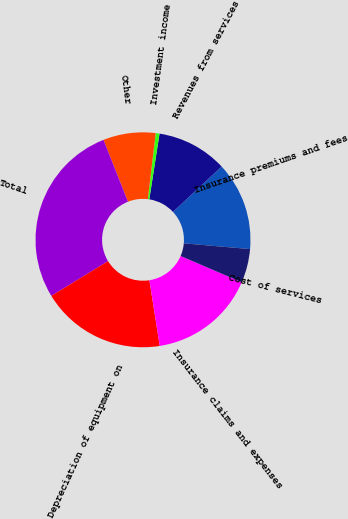<chart> <loc_0><loc_0><loc_500><loc_500><pie_chart><fcel>Insurance premiums and fees<fcel>Revenues from services<fcel>Investment income<fcel>Other<fcel>Total<fcel>Depreciation of equipment on<fcel>Insurance claims and expenses<fcel>Cost of services<nl><fcel>13.32%<fcel>10.6%<fcel>0.57%<fcel>7.88%<fcel>27.75%<fcel>18.75%<fcel>16.04%<fcel>5.09%<nl></chart> 